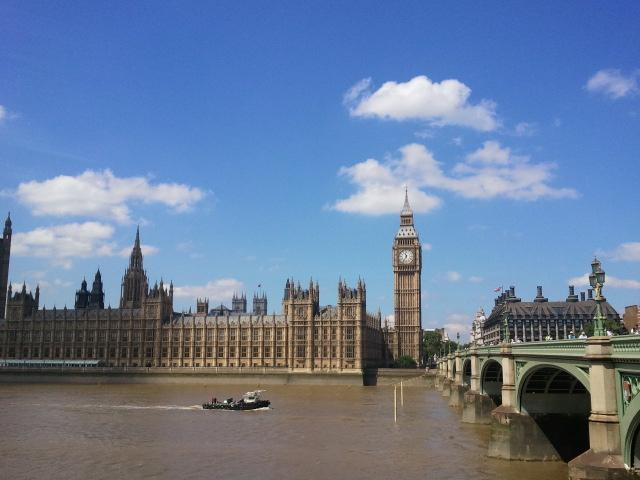What period of the day is shown in the image? Please explain your reasoning. morning. The period of time shown is morning daytime. 